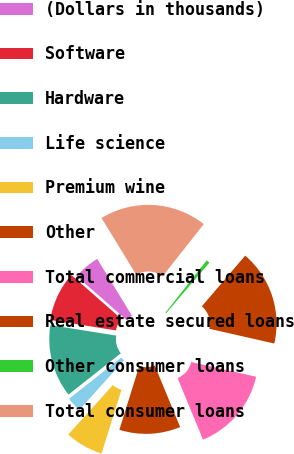Convert chart to OTSL. <chart><loc_0><loc_0><loc_500><loc_500><pie_chart><fcel>(Dollars in thousands)<fcel>Software<fcel>Hardware<fcel>Life science<fcel>Premium wine<fcel>Other<fcel>Total commercial loans<fcel>Real estate secured loans<fcel>Other consumer loans<fcel>Total consumer loans<nl><fcel>4.79%<fcel>8.96%<fcel>13.13%<fcel>2.7%<fcel>6.87%<fcel>11.04%<fcel>15.21%<fcel>17.3%<fcel>0.62%<fcel>19.38%<nl></chart> 